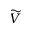<formula> <loc_0><loc_0><loc_500><loc_500>\widetilde { V }</formula> 